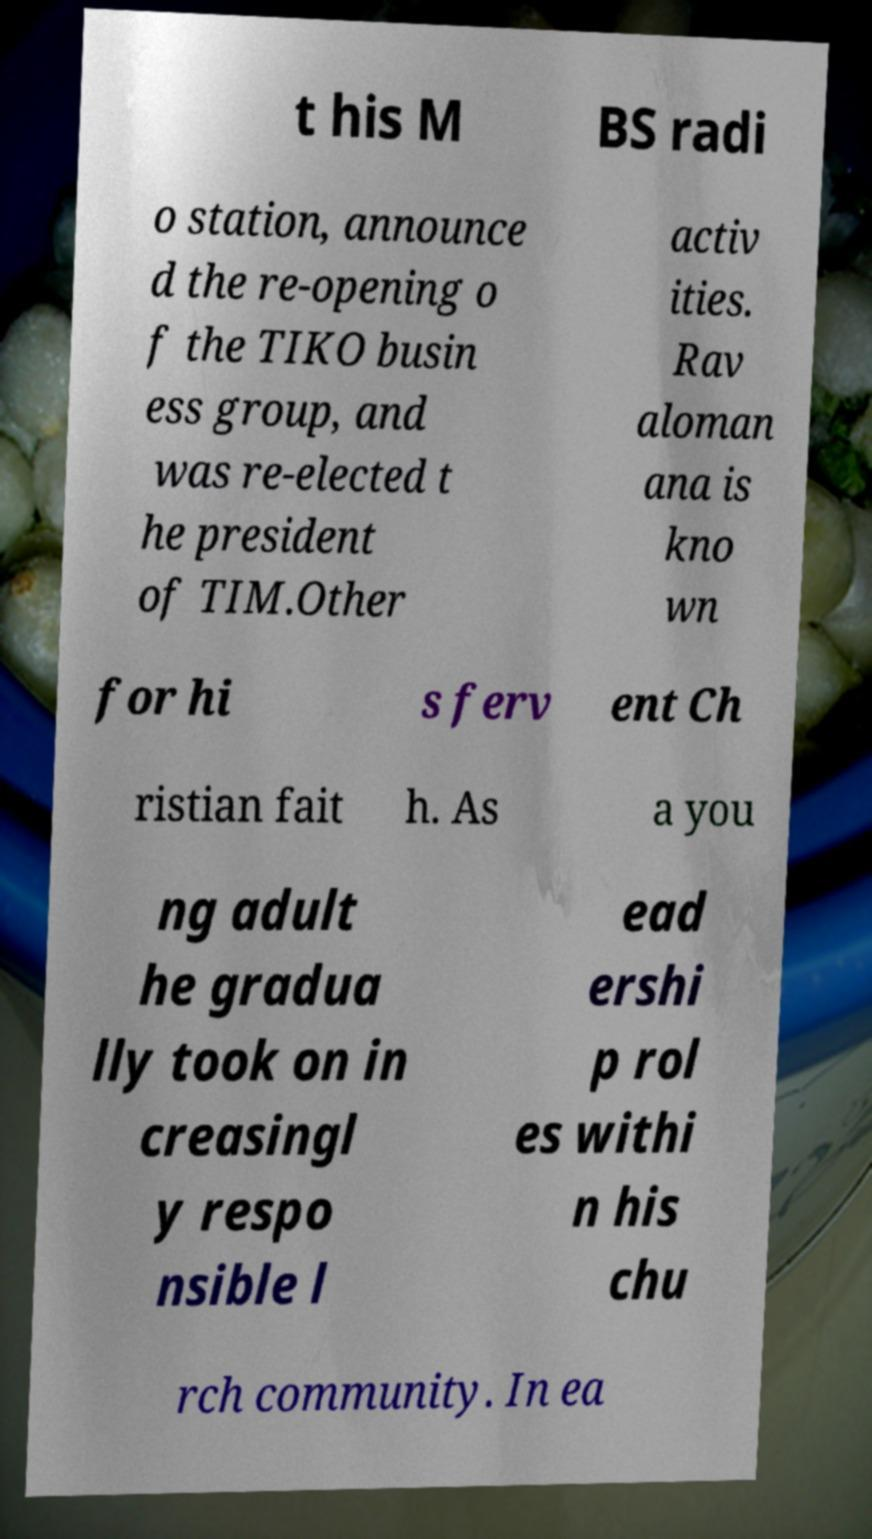Could you assist in decoding the text presented in this image and type it out clearly? t his M BS radi o station, announce d the re-opening o f the TIKO busin ess group, and was re-elected t he president of TIM.Other activ ities. Rav aloman ana is kno wn for hi s ferv ent Ch ristian fait h. As a you ng adult he gradua lly took on in creasingl y respo nsible l ead ershi p rol es withi n his chu rch community. In ea 